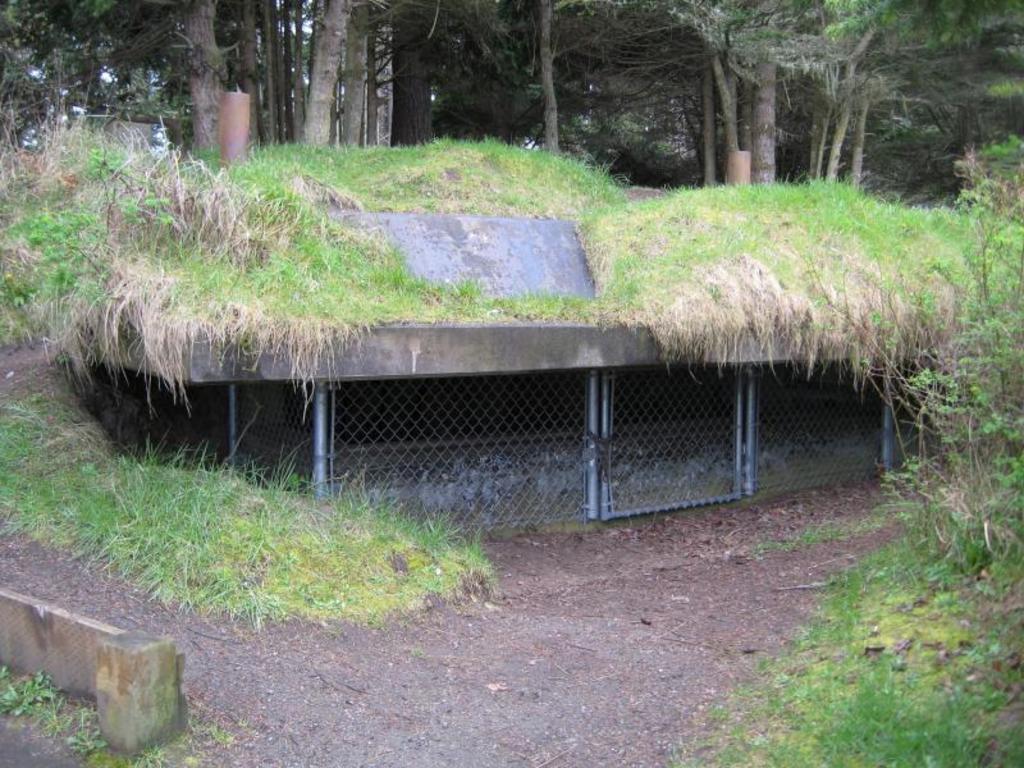Can you describe this image briefly? In this picture I can observe grass on the land. On the right side there are some plants. In the background there are trees. 